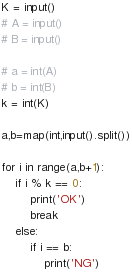<code> <loc_0><loc_0><loc_500><loc_500><_Python_>K = input()
# A = input()
# B = input()

# a = int(A)
# b = int(B)
k = int(K)

a,b=map(int,input().split())

for i in range(a,b+1):
	if i % k == 0:
		print('OK')
		break
	else:
		if i == b:
			print('NG')
</code> 